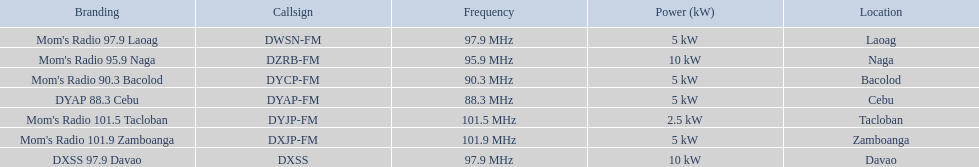Which stations consume under 10kw of power? Mom's Radio 97.9 Laoag, Mom's Radio 90.3 Bacolod, DYAP 88.3 Cebu, Mom's Radio 101.5 Tacloban, Mom's Radio 101.9 Zamboanga. Are there any stations utilizing below 5kw of power, and if yes, can you name them? Mom's Radio 101.5 Tacloban. Parse the table in full. {'header': ['Branding', 'Callsign', 'Frequency', 'Power (kW)', 'Location'], 'rows': [["Mom's Radio 97.9 Laoag", 'DWSN-FM', '97.9\xa0MHz', '5\xa0kW', 'Laoag'], ["Mom's Radio 95.9 Naga", 'DZRB-FM', '95.9\xa0MHz', '10\xa0kW', 'Naga'], ["Mom's Radio 90.3 Bacolod", 'DYCP-FM', '90.3\xa0MHz', '5\xa0kW', 'Bacolod'], ['DYAP 88.3 Cebu', 'DYAP-FM', '88.3\xa0MHz', '5\xa0kW', 'Cebu'], ["Mom's Radio 101.5 Tacloban", 'DYJP-FM', '101.5\xa0MHz', '2.5\xa0kW', 'Tacloban'], ["Mom's Radio 101.9 Zamboanga", 'DXJP-FM', '101.9\xa0MHz', '5\xa0kW', 'Zamboanga'], ['DXSS 97.9 Davao', 'DXSS', '97.9\xa0MHz', '10\xa0kW', 'Davao']]} 